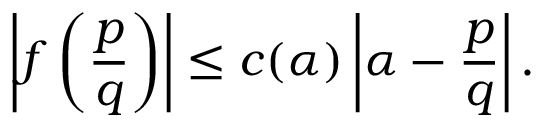<formula> <loc_0><loc_0><loc_500><loc_500>\left | f \left ( { \frac { p } { q } } \right ) \right | \leq c ( \alpha ) \left | \alpha - { \frac { p } { q } } \right | .</formula> 